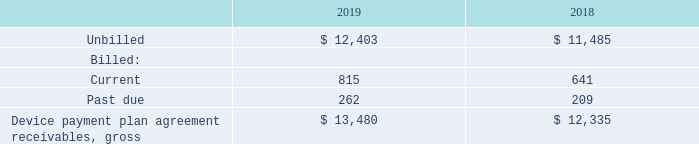Subsequent to origination, the delinquency and write-off experience is monitored as key credit quality indicators for the portfolio of device payment plan agreement receivables and fixed-term service plans. The extent of collection efforts with respect to a particular customer are based on the results of proprietary custom empirically derived internal behavioral-scoring models that analyze the customer’s past performance to predict the likelihood of the customer falling further delinquent.
These customer-scoring models assess a number of variables, including origination characteristics, customer account history and payment patterns. Based on the score derived from these models, accounts are grouped by risk category to determine the collection strategy to be applied to such accounts.
Collection performance results and the credit quality of device payment plan agreement receivables are continuously monitored based on a variety of metrics, including aging. An account is considered to be delinquent and in default status if there are unpaid charges remaining on the account on the day after the bill’s due date.
At December 31, 2019 and 2018, the balance and aging of the device payment plan agreement receivables on a gross basis was as follows:
What is the function of customer-scoring models? Assess a number of variables, including origination characteristics, customer account history and payment patterns. When is an account considered to be delinquent? If there are unpaid charges remaining on the account on the day after the bill’s due date. What was the current billed in 2019? 815. What is the increase / (decrease) in the unbilled from 2018 to 2019? 12,403 - 11,485
Answer: 918. What is the average current billed for 2018 and 2019? (815 + 641) / 2
Answer: 728. What is the increase / (decrease) in the Device payment plan agreement receivables, gross from 2018 to 2019? 13,480 - 12,335
Answer: 1145. 